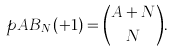<formula> <loc_0><loc_0><loc_500><loc_500>\ p A B _ { N } ( + 1 ) = \binom { A + N } { N } .</formula> 